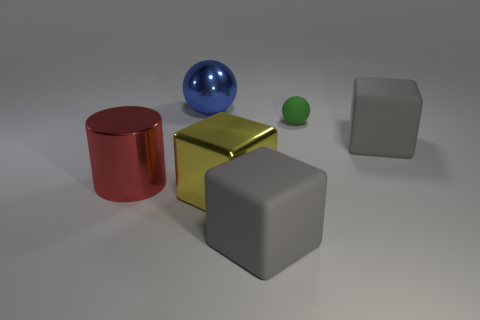Is there any other thing that is the same size as the matte sphere?
Your answer should be compact. No. There is another thing that is the same shape as the blue thing; what is its color?
Your answer should be very brief. Green. What number of big metal blocks have the same color as the large metallic cylinder?
Your response must be concise. 0. Is the yellow metallic object the same size as the shiny ball?
Ensure brevity in your answer.  Yes. What is the tiny green ball made of?
Offer a very short reply. Rubber. There is a big sphere that is made of the same material as the red cylinder; what color is it?
Keep it short and to the point. Blue. Is the big yellow cube made of the same material as the blue object that is behind the yellow object?
Ensure brevity in your answer.  Yes. What number of tiny brown cylinders are the same material as the red thing?
Provide a short and direct response. 0. There is a thing that is to the left of the blue shiny thing; what shape is it?
Provide a short and direct response. Cylinder. Are the gray cube that is in front of the yellow block and the big object right of the green matte object made of the same material?
Your answer should be compact. Yes. 